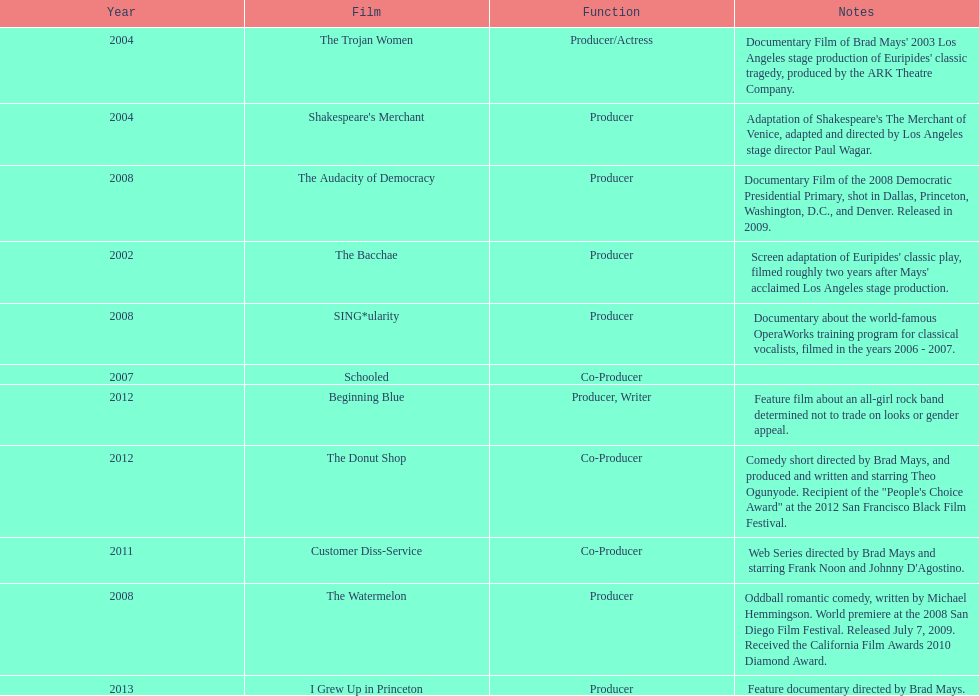During which year did ms. starfelt's film production reach its peak? 2008. 